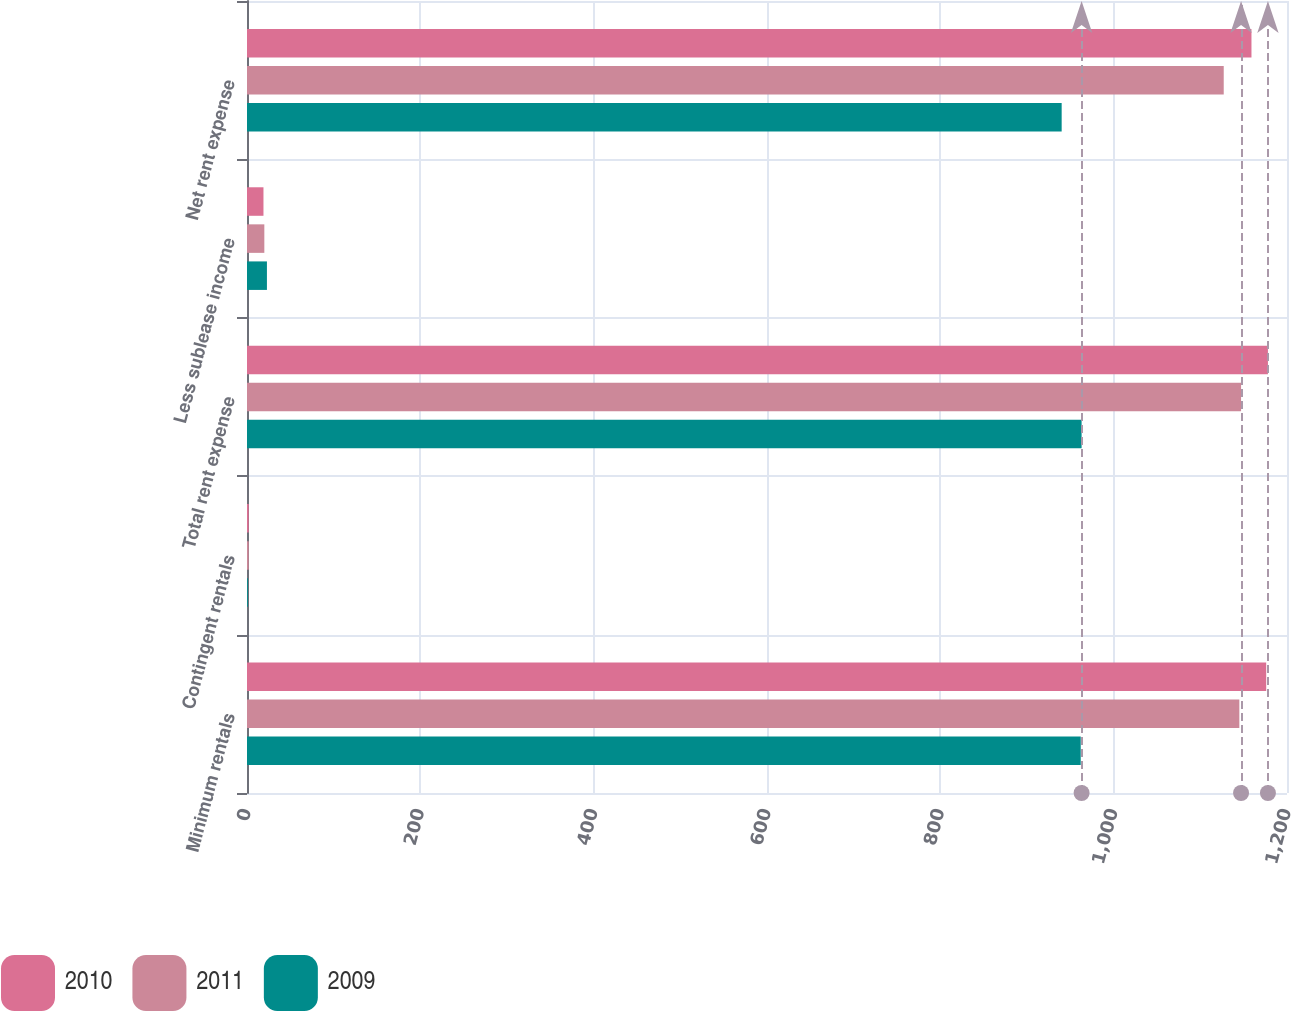Convert chart to OTSL. <chart><loc_0><loc_0><loc_500><loc_500><stacked_bar_chart><ecel><fcel>Minimum rentals<fcel>Contingent rentals<fcel>Total rent expense<fcel>Less sublease income<fcel>Net rent expense<nl><fcel>2010<fcel>1176<fcel>2<fcel>1178<fcel>19<fcel>1159<nl><fcel>2011<fcel>1145<fcel>2<fcel>1147<fcel>20<fcel>1127<nl><fcel>2009<fcel>962<fcel>1<fcel>963<fcel>23<fcel>940<nl></chart> 